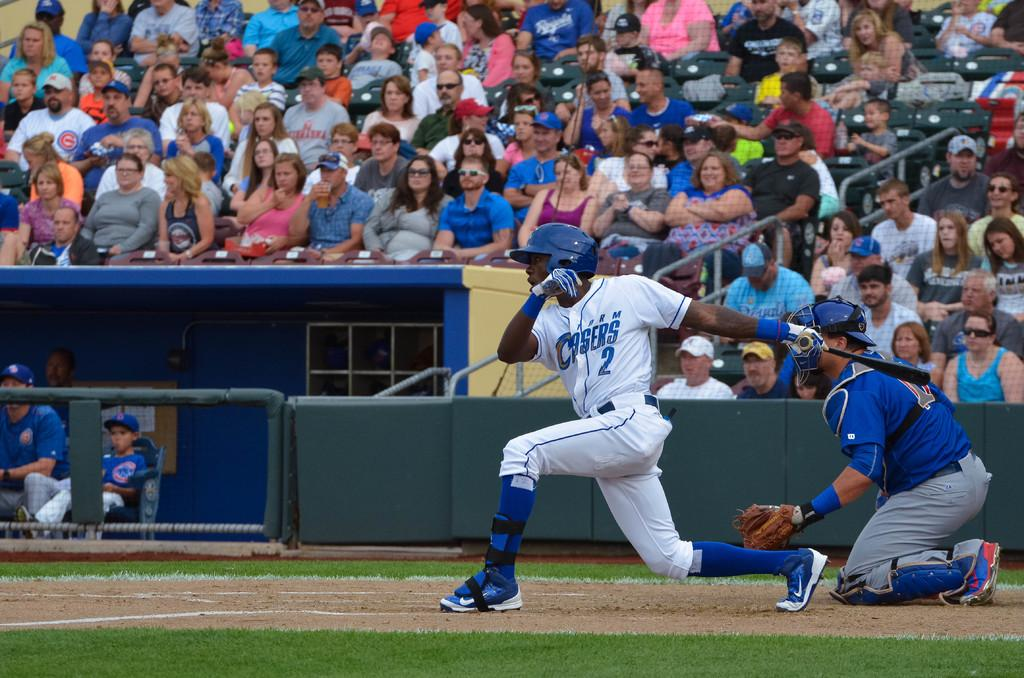<image>
Provide a brief description of the given image. a baseball player batting in a Storm Chasers 2 jersey 